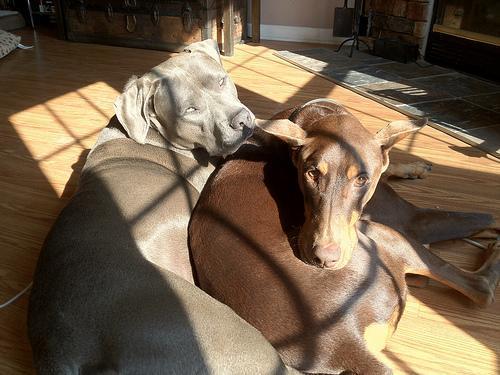How many dogs?
Give a very brief answer. 2. How many dogs are there?
Give a very brief answer. 2. How many les do the dogs have?
Give a very brief answer. 4. How many brown dogs?
Give a very brief answer. 1. 